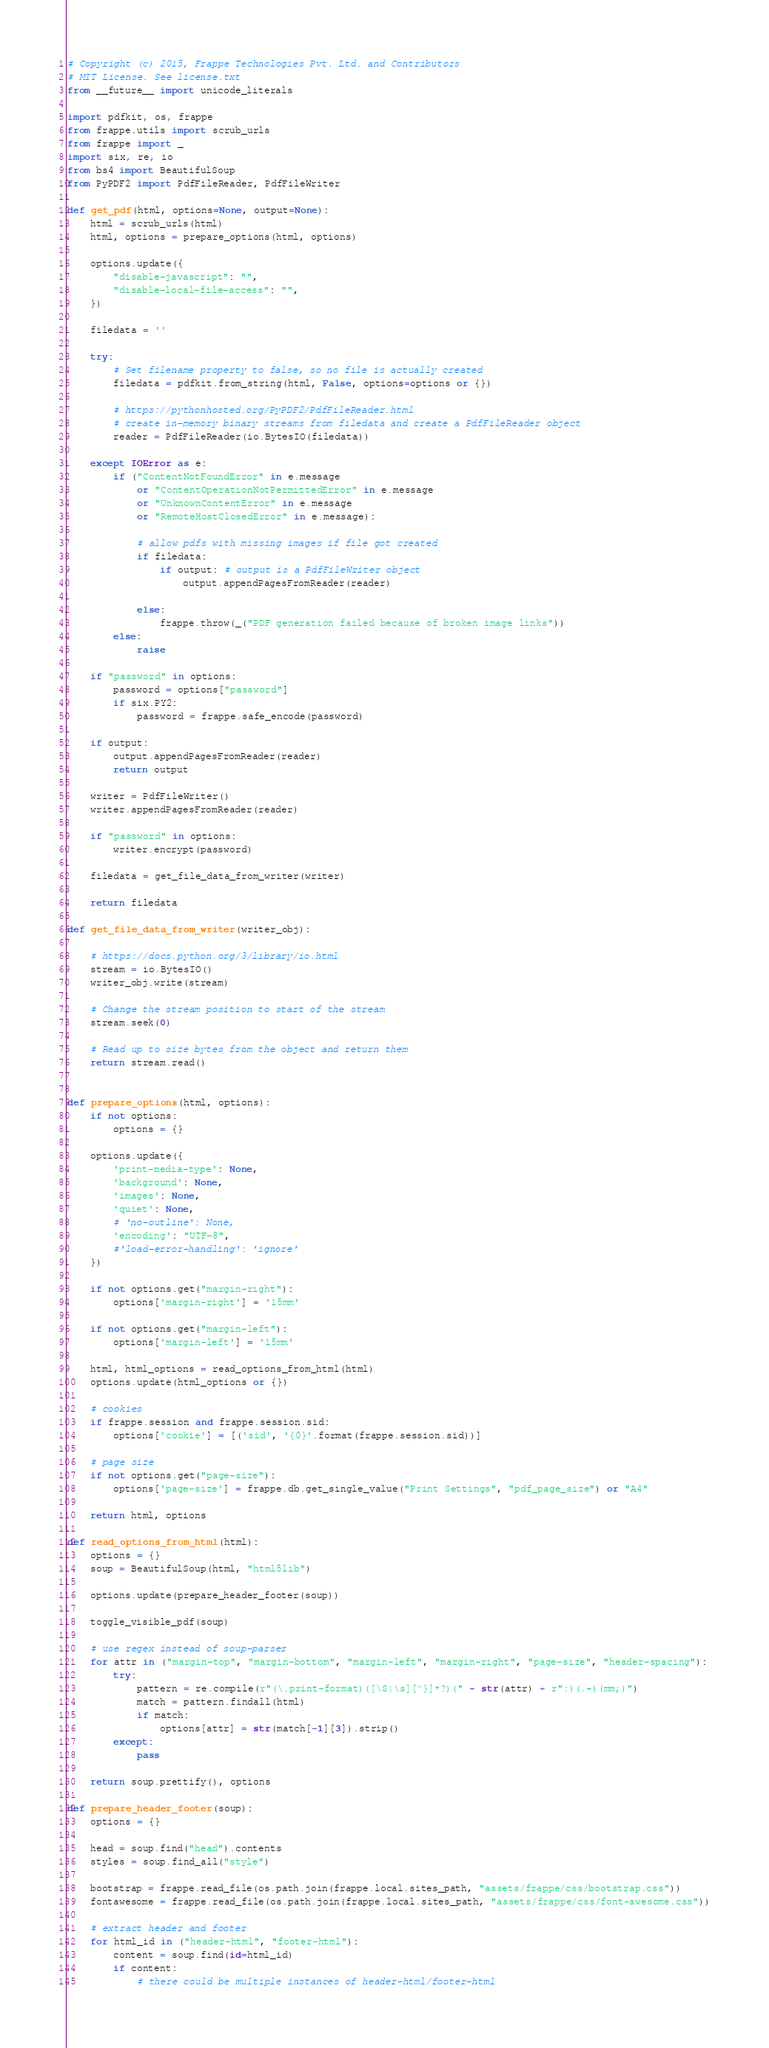Convert code to text. <code><loc_0><loc_0><loc_500><loc_500><_Python_># Copyright (c) 2015, Frappe Technologies Pvt. Ltd. and Contributors
# MIT License. See license.txt
from __future__ import unicode_literals

import pdfkit, os, frappe
from frappe.utils import scrub_urls
from frappe import _
import six, re, io
from bs4 import BeautifulSoup
from PyPDF2 import PdfFileReader, PdfFileWriter

def get_pdf(html, options=None, output=None):
	html = scrub_urls(html)
	html, options = prepare_options(html, options)

	options.update({
		"disable-javascript": "",
		"disable-local-file-access": "",
	})

	filedata = ''

	try:
		# Set filename property to false, so no file is actually created
		filedata = pdfkit.from_string(html, False, options=options or {})

		# https://pythonhosted.org/PyPDF2/PdfFileReader.html
		# create in-memory binary streams from filedata and create a PdfFileReader object
		reader = PdfFileReader(io.BytesIO(filedata))

	except IOError as e:
		if ("ContentNotFoundError" in e.message
			or "ContentOperationNotPermittedError" in e.message
			or "UnknownContentError" in e.message
			or "RemoteHostClosedError" in e.message):

			# allow pdfs with missing images if file got created
			if filedata:
				if output: # output is a PdfFileWriter object
					output.appendPagesFromReader(reader)

			else:
				frappe.throw(_("PDF generation failed because of broken image links"))
		else:
			raise

	if "password" in options:
		password = options["password"]
		if six.PY2:
			password = frappe.safe_encode(password)

	if output:
		output.appendPagesFromReader(reader)
		return output

	writer = PdfFileWriter()
	writer.appendPagesFromReader(reader)

	if "password" in options:
		writer.encrypt(password)

	filedata = get_file_data_from_writer(writer)

	return filedata

def get_file_data_from_writer(writer_obj):

	# https://docs.python.org/3/library/io.html
	stream = io.BytesIO()
	writer_obj.write(stream)

	# Change the stream position to start of the stream
	stream.seek(0)

	# Read up to size bytes from the object and return them
	return stream.read()


def prepare_options(html, options):
	if not options:
		options = {}

	options.update({
		'print-media-type': None,
		'background': None,
		'images': None,
		'quiet': None,
		# 'no-outline': None,
		'encoding': "UTF-8",
		#'load-error-handling': 'ignore'
	})

	if not options.get("margin-right"):
		options['margin-right'] = '15mm'

	if not options.get("margin-left"):
		options['margin-left'] = '15mm'

	html, html_options = read_options_from_html(html)
	options.update(html_options or {})

	# cookies
	if frappe.session and frappe.session.sid:
		options['cookie'] = [('sid', '{0}'.format(frappe.session.sid))]

	# page size
	if not options.get("page-size"):
		options['page-size'] = frappe.db.get_single_value("Print Settings", "pdf_page_size") or "A4"

	return html, options

def read_options_from_html(html):
	options = {}
	soup = BeautifulSoup(html, "html5lib")

	options.update(prepare_header_footer(soup))

	toggle_visible_pdf(soup)

	# use regex instead of soup-parser
	for attr in ("margin-top", "margin-bottom", "margin-left", "margin-right", "page-size", "header-spacing"):
		try:
			pattern = re.compile(r"(\.print-format)([\S|\s][^}]*?)(" + str(attr) + r":)(.+)(mm;)")
			match = pattern.findall(html)
			if match:
				options[attr] = str(match[-1][3]).strip()
		except:
			pass

	return soup.prettify(), options

def prepare_header_footer(soup):
	options = {}

	head = soup.find("head").contents
	styles = soup.find_all("style")

	bootstrap = frappe.read_file(os.path.join(frappe.local.sites_path, "assets/frappe/css/bootstrap.css"))
	fontawesome = frappe.read_file(os.path.join(frappe.local.sites_path, "assets/frappe/css/font-awesome.css"))

	# extract header and footer
	for html_id in ("header-html", "footer-html"):
		content = soup.find(id=html_id)
		if content:
			# there could be multiple instances of header-html/footer-html</code> 